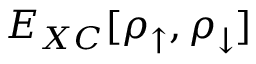<formula> <loc_0><loc_0><loc_500><loc_500>E _ { X C } [ \rho _ { \uparrow } , \rho _ { \downarrow } ]</formula> 